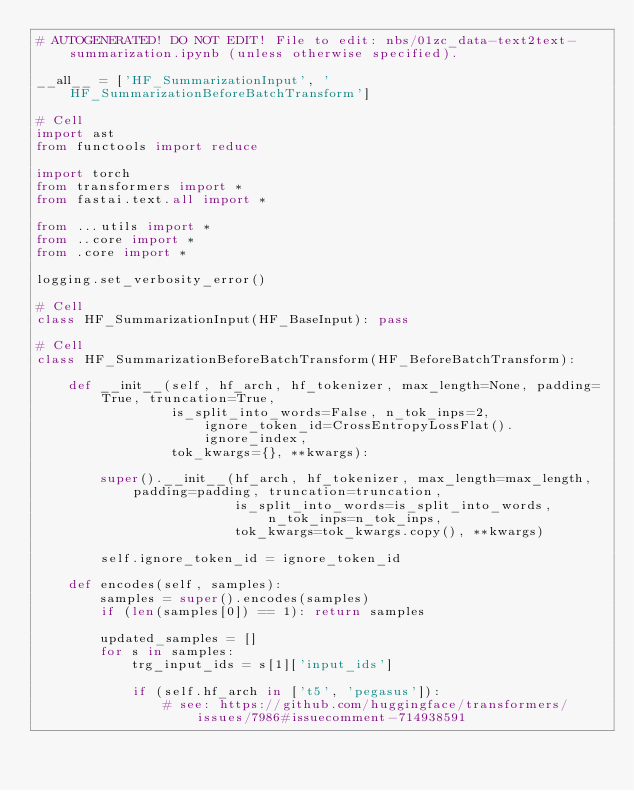Convert code to text. <code><loc_0><loc_0><loc_500><loc_500><_Python_># AUTOGENERATED! DO NOT EDIT! File to edit: nbs/01zc_data-text2text-summarization.ipynb (unless otherwise specified).

__all__ = ['HF_SummarizationInput', 'HF_SummarizationBeforeBatchTransform']

# Cell
import ast
from functools import reduce

import torch
from transformers import *
from fastai.text.all import *

from ...utils import *
from ..core import *
from .core import *

logging.set_verbosity_error()

# Cell
class HF_SummarizationInput(HF_BaseInput): pass

# Cell
class HF_SummarizationBeforeBatchTransform(HF_BeforeBatchTransform):

    def __init__(self, hf_arch, hf_tokenizer, max_length=None, padding=True, truncation=True,
                 is_split_into_words=False, n_tok_inps=2, ignore_token_id=CrossEntropyLossFlat().ignore_index,
                 tok_kwargs={}, **kwargs):

        super().__init__(hf_arch, hf_tokenizer, max_length=max_length, padding=padding, truncation=truncation,
                         is_split_into_words=is_split_into_words, n_tok_inps=n_tok_inps,
                         tok_kwargs=tok_kwargs.copy(), **kwargs)

        self.ignore_token_id = ignore_token_id

    def encodes(self, samples):
        samples = super().encodes(samples)
        if (len(samples[0]) == 1): return samples

        updated_samples = []
        for s in samples:
            trg_input_ids = s[1]['input_ids']

            if (self.hf_arch in ['t5', 'pegasus']):
                # see: https://github.com/huggingface/transformers/issues/7986#issuecomment-714938591</code> 